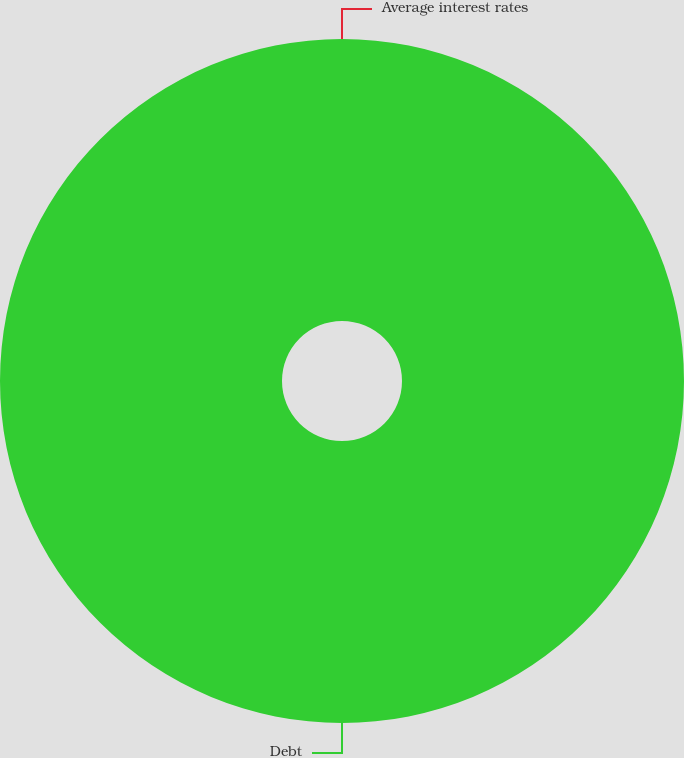Convert chart. <chart><loc_0><loc_0><loc_500><loc_500><pie_chart><fcel>Debt<fcel>Average interest rates<nl><fcel>100.0%<fcel>0.0%<nl></chart> 